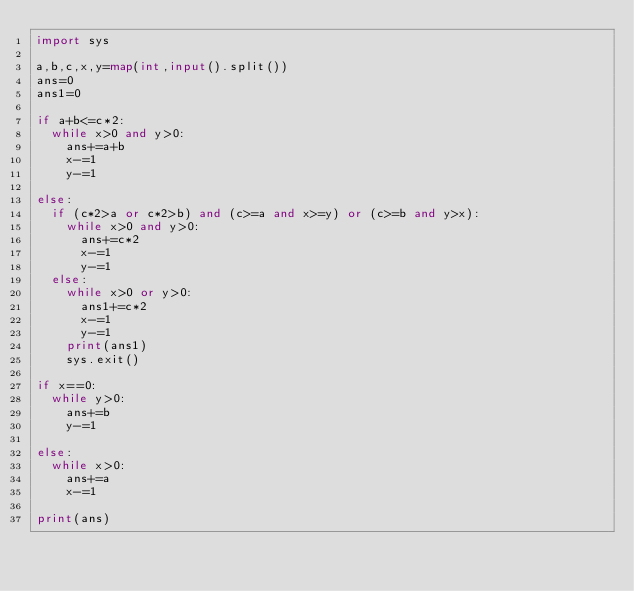<code> <loc_0><loc_0><loc_500><loc_500><_Python_>import sys

a,b,c,x,y=map(int,input().split())
ans=0
ans1=0

if a+b<=c*2:
  while x>0 and y>0:
    ans+=a+b
    x-=1
    y-=1

else:
  if (c*2>a or c*2>b) and (c>=a and x>=y) or (c>=b and y>x):
    while x>0 and y>0:
      ans+=c*2
      x-=1
      y-=1
  else:
    while x>0 or y>0:
      ans1+=c*2
      x-=1
      y-=1
    print(ans1)
    sys.exit()

if x==0:
  while y>0:
    ans+=b
    y-=1

else:
  while x>0:
    ans+=a
    x-=1

print(ans)</code> 